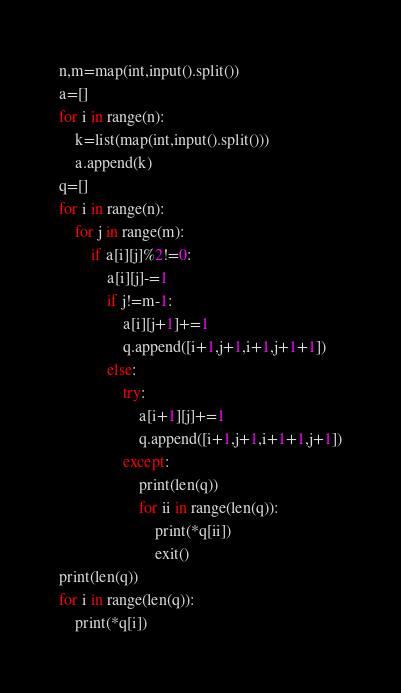Convert code to text. <code><loc_0><loc_0><loc_500><loc_500><_Python_>n,m=map(int,input().split())
a=[]
for i in range(n):
	k=list(map(int,input().split()))
	a.append(k)
q=[]
for i in range(n):
	for j in range(m):
		if a[i][j]%2!=0:
			a[i][j]-=1
			if j!=m-1:
				a[i][j+1]+=1
				q.append([i+1,j+1,i+1,j+1+1])
			else:
				try:
					a[i+1][j]+=1
					q.append([i+1,j+1,i+1+1,j+1])
				except:
					print(len(q))
					for ii in range(len(q)):
						print(*q[ii])
						exit()
print(len(q))
for i in range(len(q)):
	print(*q[i])
</code> 